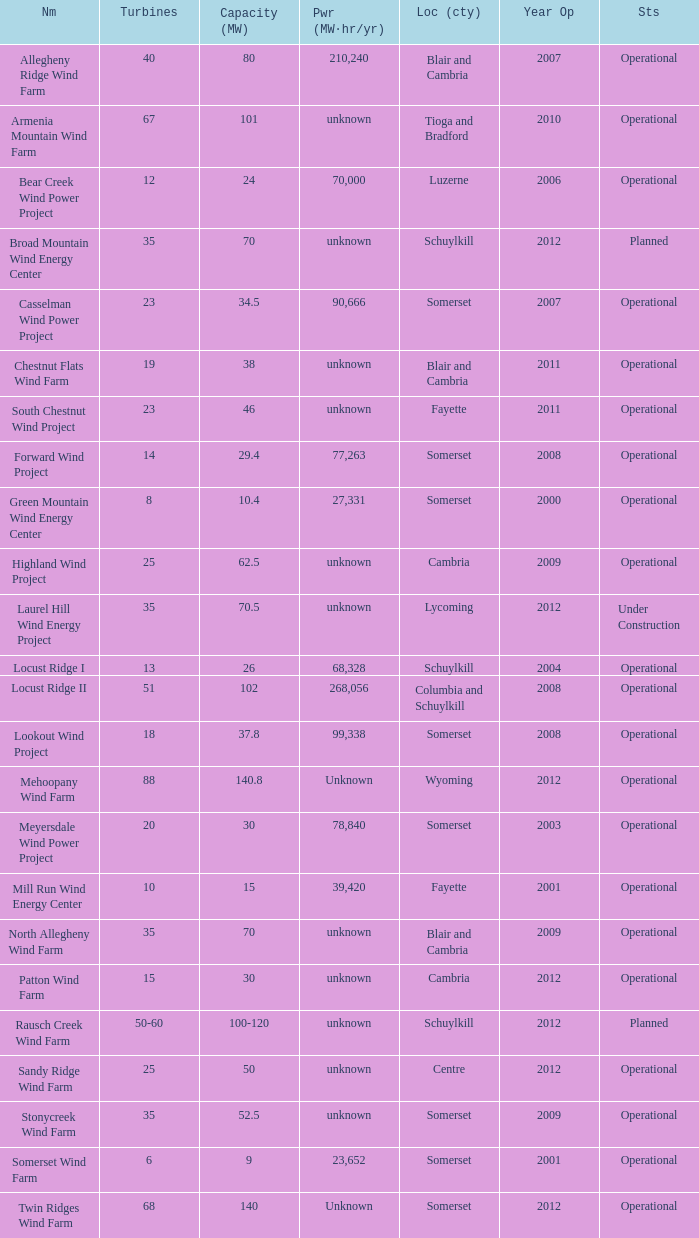What year was Fayette operational at 46? 2011.0. 